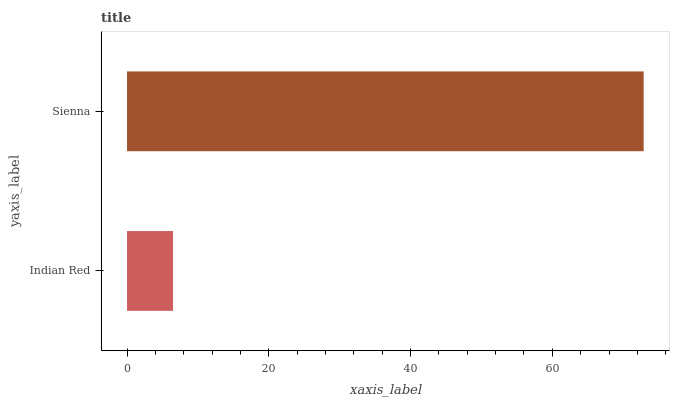Is Indian Red the minimum?
Answer yes or no. Yes. Is Sienna the maximum?
Answer yes or no. Yes. Is Sienna the minimum?
Answer yes or no. No. Is Sienna greater than Indian Red?
Answer yes or no. Yes. Is Indian Red less than Sienna?
Answer yes or no. Yes. Is Indian Red greater than Sienna?
Answer yes or no. No. Is Sienna less than Indian Red?
Answer yes or no. No. Is Sienna the high median?
Answer yes or no. Yes. Is Indian Red the low median?
Answer yes or no. Yes. Is Indian Red the high median?
Answer yes or no. No. Is Sienna the low median?
Answer yes or no. No. 